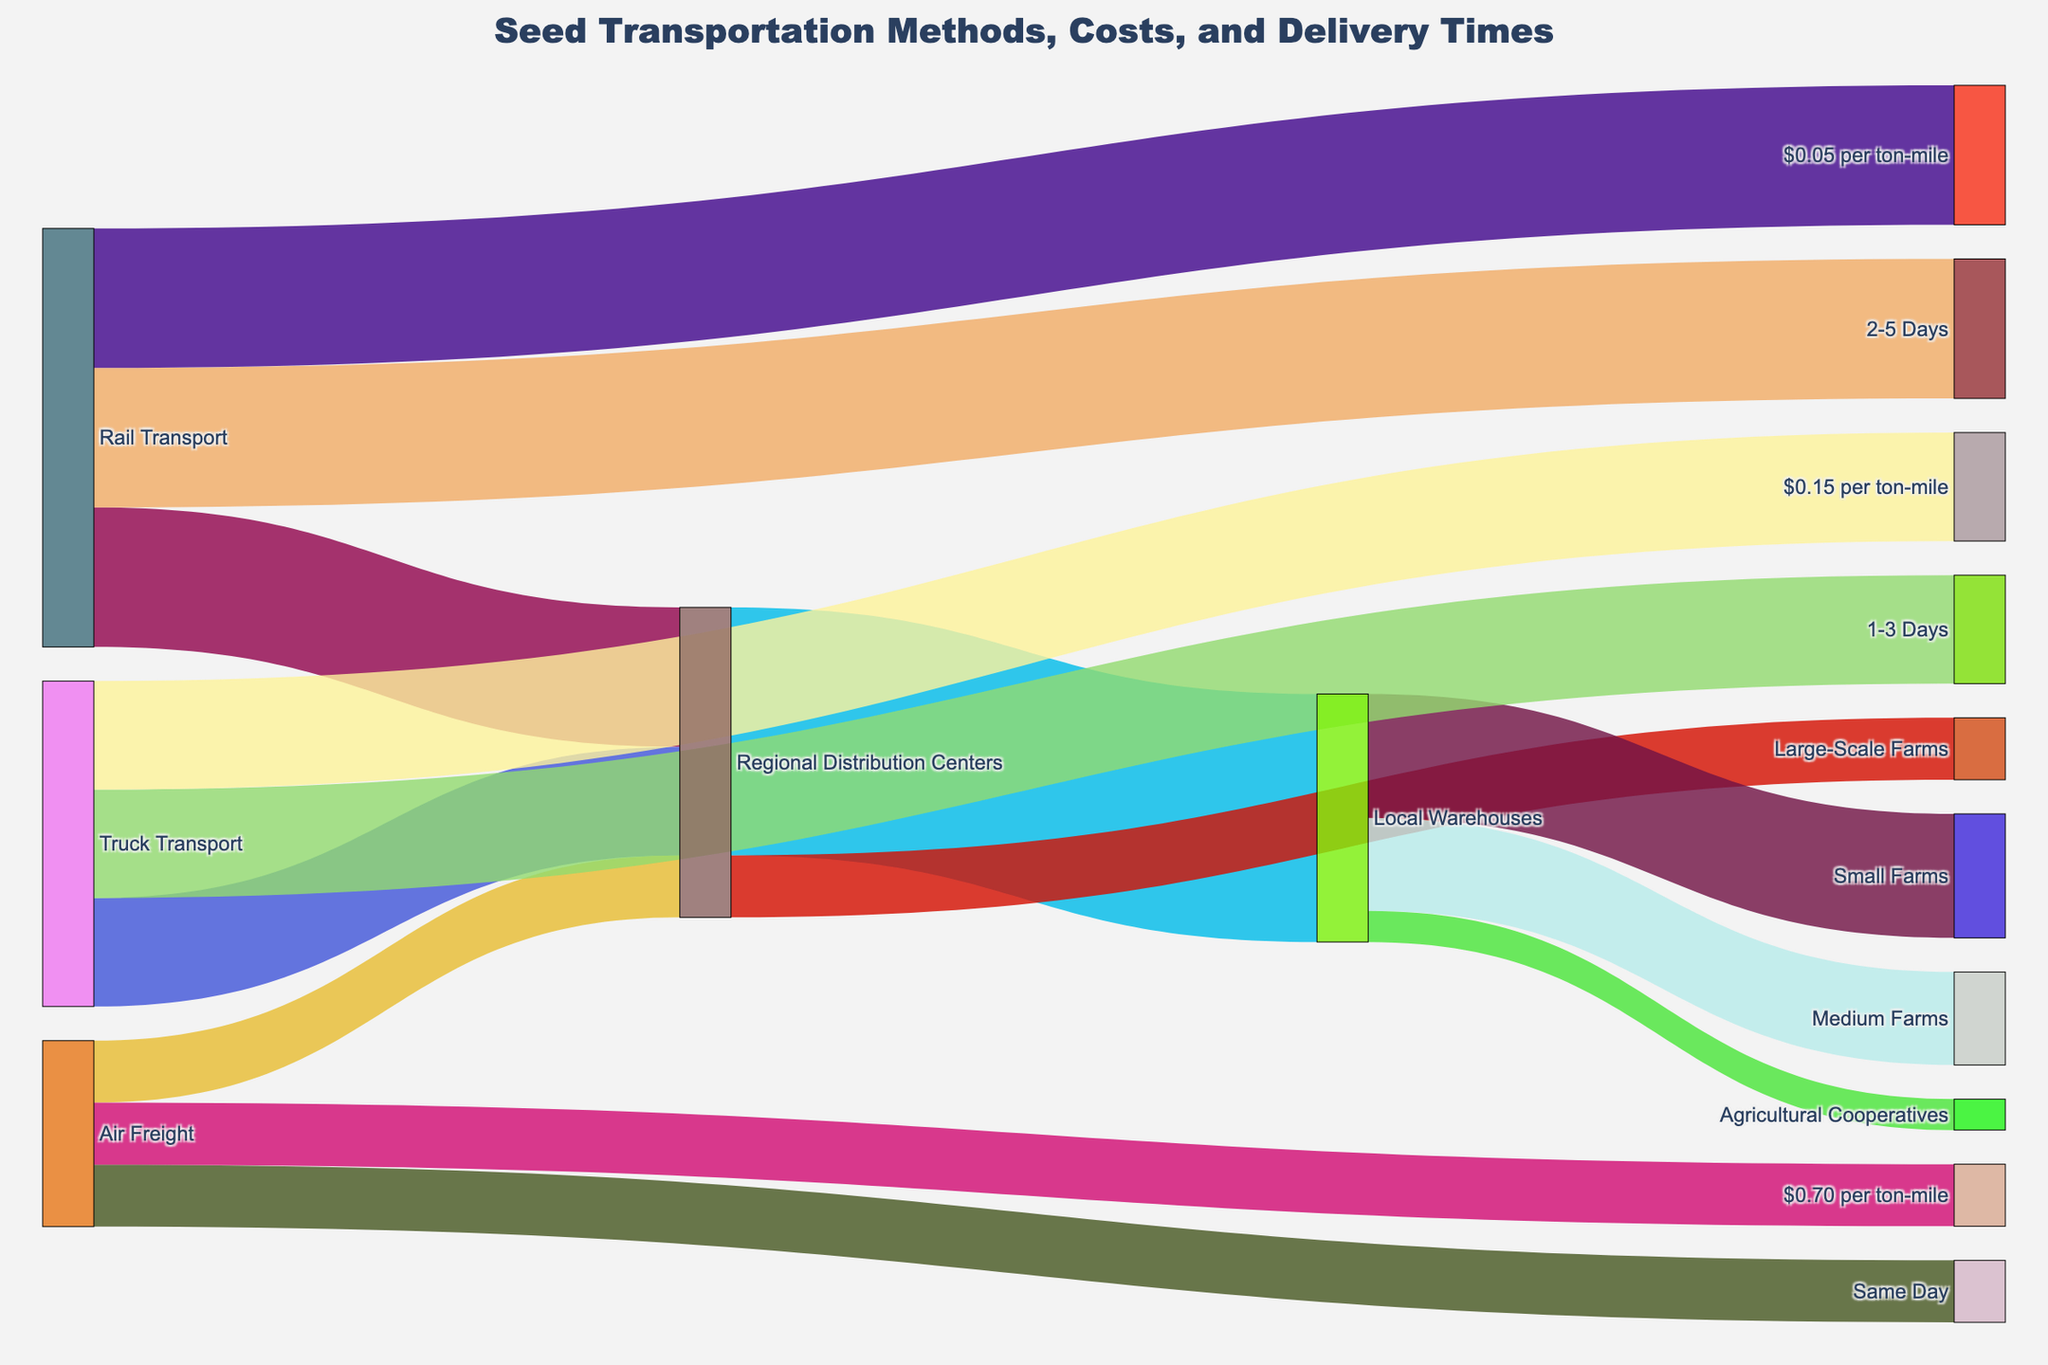What are the three transportation methods for seeds? The three transportation methods are displayed as the sources of the Sankey Diagram. The sources are "Rail Transport," "Truck Transport," and "Air Freight."
Answer: Rail Transport, Truck Transport, Air Freight What's the total value of seeds transported to Regional Distribution Centers? The diagram shows that "Rail Transport," "Truck Transport," and "Air Freight" all send seeds to Regional Distribution Centers. Adding the values yields 45 (Rail) + 35 (Truck) + 20 (Air) = 100.
Answer: 100 How many days does Truck Transport take for delivery? The time-related target for "Truck Transport" in the Sankey diagram shows the range of days. The connection shows "1-3 Days."
Answer: 1-3 Days Which transportation method has the highest cost per ton-mile? The cost per ton-mile is specified for each transportation method in the diagram. "Rail Transport" costs $0.05, "Truck Transport" costs $0.15, and "Air Freight" costs $0.70. "Air Freight" has the highest cost.
Answer: Air Freight What's the most common final destination for seeds from Regional Distribution Centers? The Sankey Diagram displays flows from Regional Distribution Centers to their final destinations. "Local Warehouses" receive the most, with a value of 80.
Answer: Local Warehouses Which final destination receives the least amount of seeds from Local Warehouses? The diagram shows three targets from Local Warehouses: Small Farms (40), Medium Farms (30), and Agricultural Cooperatives (10). "Agricultural Cooperatives" receive the least.
Answer: Agricultural Cooperatives Compare the delivery times of Rail Transport and Air Freight. Rail Transport takes "2-5 Days" while Air Freight is listed as "Same Day." Air Freight delivers significantly faster.
Answer: Air Freight delivers faster Calculate the total cost of transporting 100 tons of seeds 100 miles by each method. The costs are calculated as follows:
- Rail Transport: 100 tons * 100 miles * $0.05 = $500
- Truck Transport: 100 tons * 100 miles * $0.15 = $1,500
- Air Freight: 100 tons * 100 miles * $0.70 = $7,000
Answer: Rail: $500, Truck: $1500, Air: $7000 How does the value of seeds transported by Truck Transport compare to those transported by Air Freight? The diagram shows Truck Transport has a value of 35, while Air Freight has a value of 20. Truck Transport transports more seeds.
Answer: Truck Transport transports more What's the combined value of seeds delivered to Small and Medium Farms from Local Warehouses? Adding the values for Small Farms (40) and Medium Farms (30) yields a total: 40 + 30 = 70.
Answer: 70 